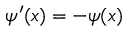Convert formula to latex. <formula><loc_0><loc_0><loc_500><loc_500>\psi ^ { \prime } ( x ) = - \psi ( x )</formula> 